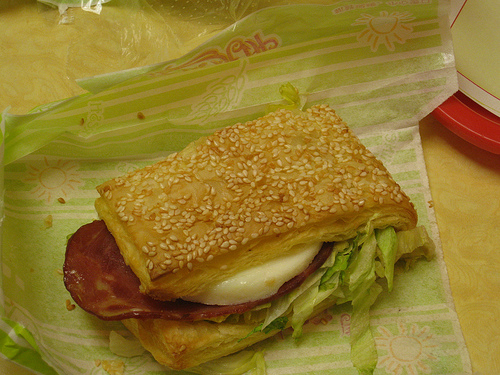<image>
Is there a burger in the cheese? No. The burger is not contained within the cheese. These objects have a different spatial relationship. 